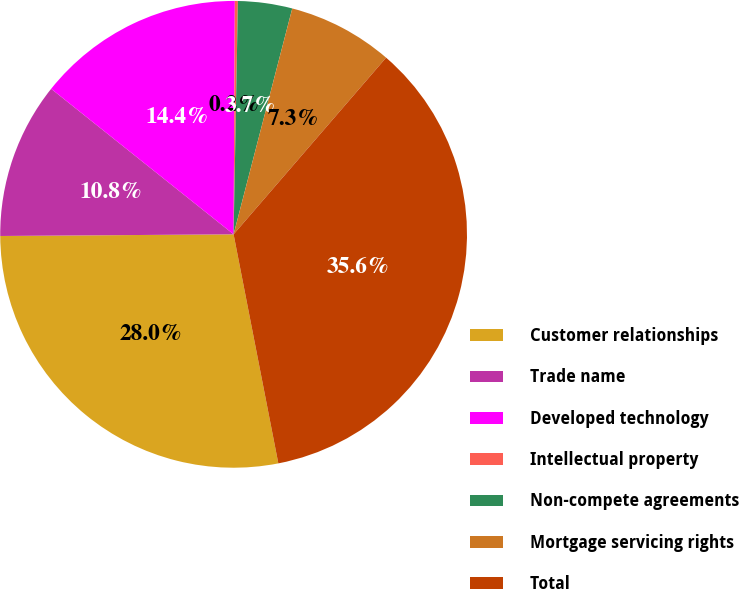<chart> <loc_0><loc_0><loc_500><loc_500><pie_chart><fcel>Customer relationships<fcel>Trade name<fcel>Developed technology<fcel>Intellectual property<fcel>Non-compete agreements<fcel>Mortgage servicing rights<fcel>Total<nl><fcel>27.96%<fcel>10.83%<fcel>14.37%<fcel>0.21%<fcel>3.75%<fcel>7.29%<fcel>35.6%<nl></chart> 